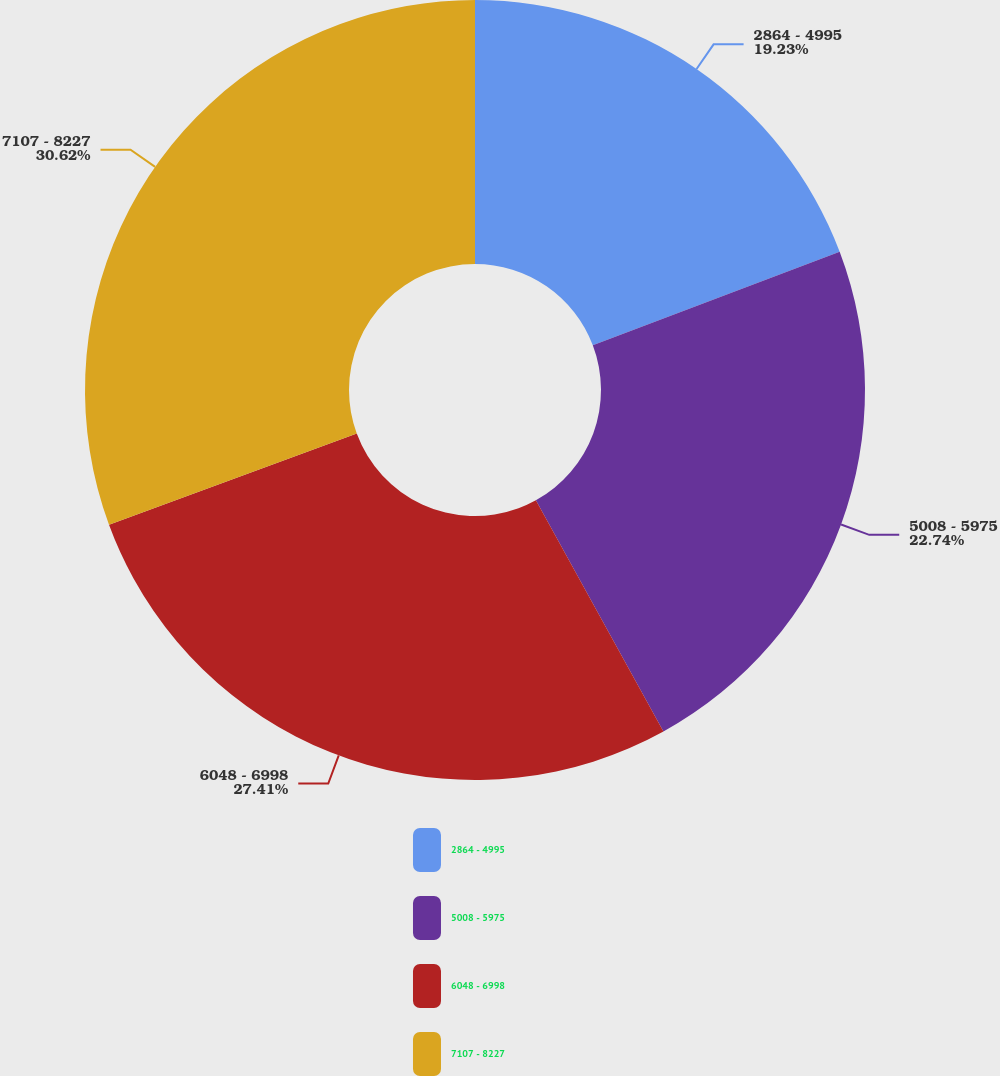<chart> <loc_0><loc_0><loc_500><loc_500><pie_chart><fcel>2864 - 4995<fcel>5008 - 5975<fcel>6048 - 6998<fcel>7107 - 8227<nl><fcel>19.23%<fcel>22.74%<fcel>27.41%<fcel>30.61%<nl></chart> 